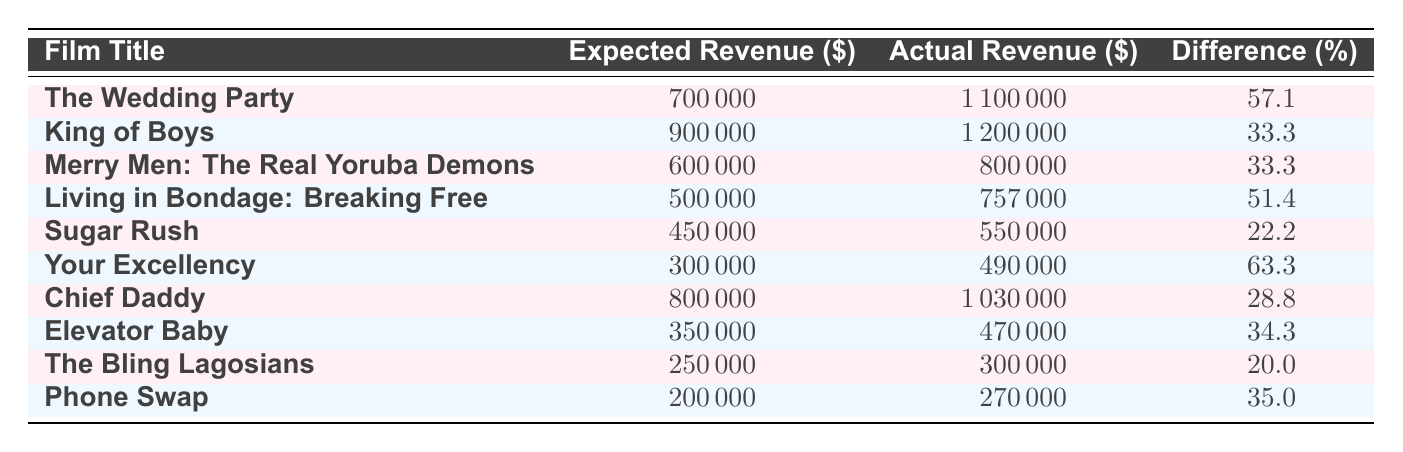What is the expected revenue for "The Wedding Party"? According to the table, for the film "The Wedding Party," the expected revenue is listed directly in the expected revenue column.
Answer: 700,000 What is the actual revenue for "King of Boys"? The table displays that the actual revenue for the film "King of Boys" is provided in the respective column.
Answer: 1,200,000 Which film has the smallest difference between expected and actual revenue? To determine the smallest difference, compare the difference percentages for all films. "The Bling Lagosians" has the smallest difference of 20%.
Answer: The Bling Lagosians Is the actual revenue for "Sugar Rush" greater than its expected revenue? By looking at the values in the table, the actual revenue for "Sugar Rush" (550,000) exceeds its expected revenue (450,000). Therefore, the answer is yes.
Answer: Yes What is the average difference percentage across all films? To find the average difference percentage, sum up all the difference percentages (57.1 + 33.3 + 33.3 + 51.4 + 22.2 + 63.3 + 28.8 + 34.3 + 20.0 + 35.0 =  393.1) and then divide by the number of films (10). Thus, the calculation is 393.1 / 10, which results in 39.31.
Answer: 39.31 Which film produced the highest percentage difference between expected and actual revenue? Analyzing the percentage difference column, "Your Excellency" shows the highest difference at 63.3%.
Answer: Your Excellency Did any film have actual revenue that fell short of the expected revenue? Reviewing the data, "Merry Men: The Real Yoruba Demons" had actual revenue (800,000) that was less than expected (600,000). Therefore, the answer is no.
Answer: No What is the total expected revenue for all listed films? To calculate the total expected revenue, sum the expected revenue for each film (700,000 + 900,000 + 600,000 + 500,000 + 450,000 + 300,000 + 800,000 + 350,000 + 250,000 + 200,000 = 4,500,000).
Answer: 4,500,000 Which two films had the closest expected revenue figures? By comparing the expected revenues, "Living in Bondage: Breaking Free" (500,000) and "Sugar Rush" (450,000) have the closest figures.
Answer: Living in Bondage: Breaking Free and Sugar Rush 